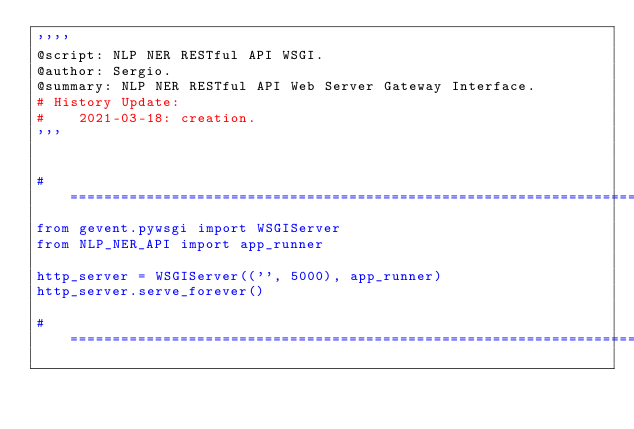<code> <loc_0><loc_0><loc_500><loc_500><_Python_>''''
@script: NLP NER RESTful API WSGI.
@author: Sergio.
@summary: NLP NER RESTful API Web Server Gateway Interface.
# History Update:
#    2021-03-18: creation.
'''


# ==================================================================================================
from gevent.pywsgi import WSGIServer
from NLP_NER_API import app_runner

http_server = WSGIServer(('', 5000), app_runner)
http_server.serve_forever()

# ==================================================================================================
</code> 